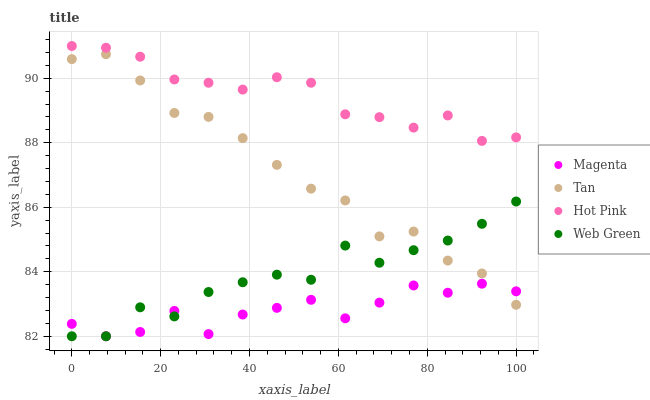Does Magenta have the minimum area under the curve?
Answer yes or no. Yes. Does Hot Pink have the maximum area under the curve?
Answer yes or no. Yes. Does Tan have the minimum area under the curve?
Answer yes or no. No. Does Tan have the maximum area under the curve?
Answer yes or no. No. Is Hot Pink the smoothest?
Answer yes or no. Yes. Is Web Green the roughest?
Answer yes or no. Yes. Is Tan the smoothest?
Answer yes or no. No. Is Tan the roughest?
Answer yes or no. No. Does Magenta have the lowest value?
Answer yes or no. Yes. Does Tan have the lowest value?
Answer yes or no. No. Does Hot Pink have the highest value?
Answer yes or no. Yes. Does Tan have the highest value?
Answer yes or no. No. Is Magenta less than Hot Pink?
Answer yes or no. Yes. Is Hot Pink greater than Magenta?
Answer yes or no. Yes. Does Web Green intersect Magenta?
Answer yes or no. Yes. Is Web Green less than Magenta?
Answer yes or no. No. Is Web Green greater than Magenta?
Answer yes or no. No. Does Magenta intersect Hot Pink?
Answer yes or no. No. 